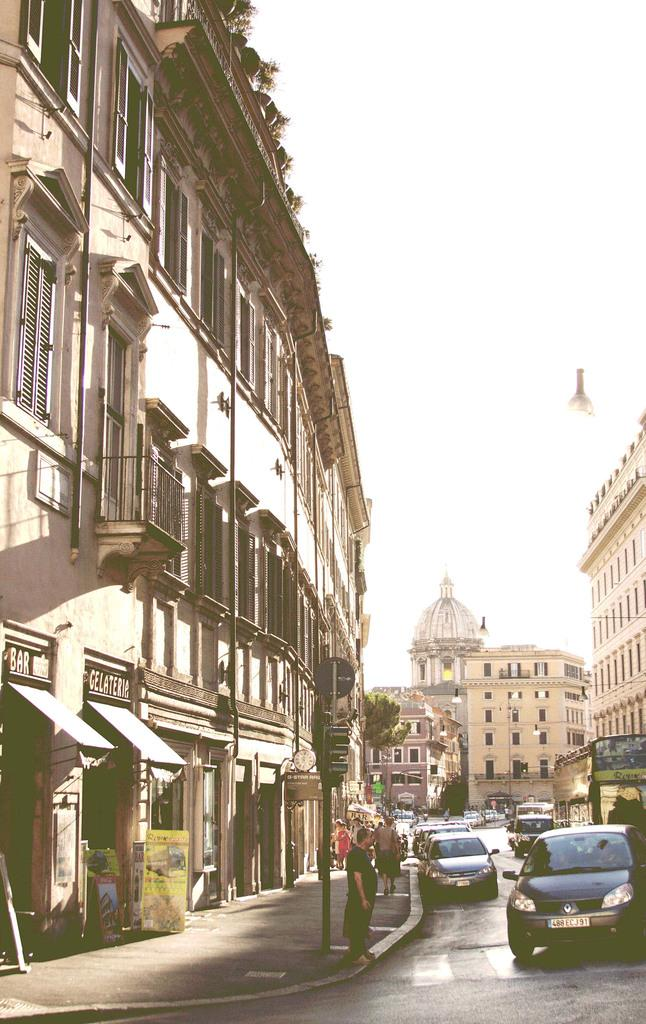What type of structures can be seen in the image? There are buildings in the image. What mode of transportation can be seen on the road at the bottom of the image? Cars are visible on the road at the bottom of the image. Are there any human figures present in the image? Yes, there are people in the image. What type of vertical structure can be seen in the image? There is a traffic pole in the image. What can be seen in the background of the image? The sky and a tree are visible in the background of the image. What type of nut is being used to sail the boat in the image? There is no boat or nut present in the image. Are there any police officers visible in the image? There is no mention of police officers in the provided facts, so we cannot determine their presence in the image. 